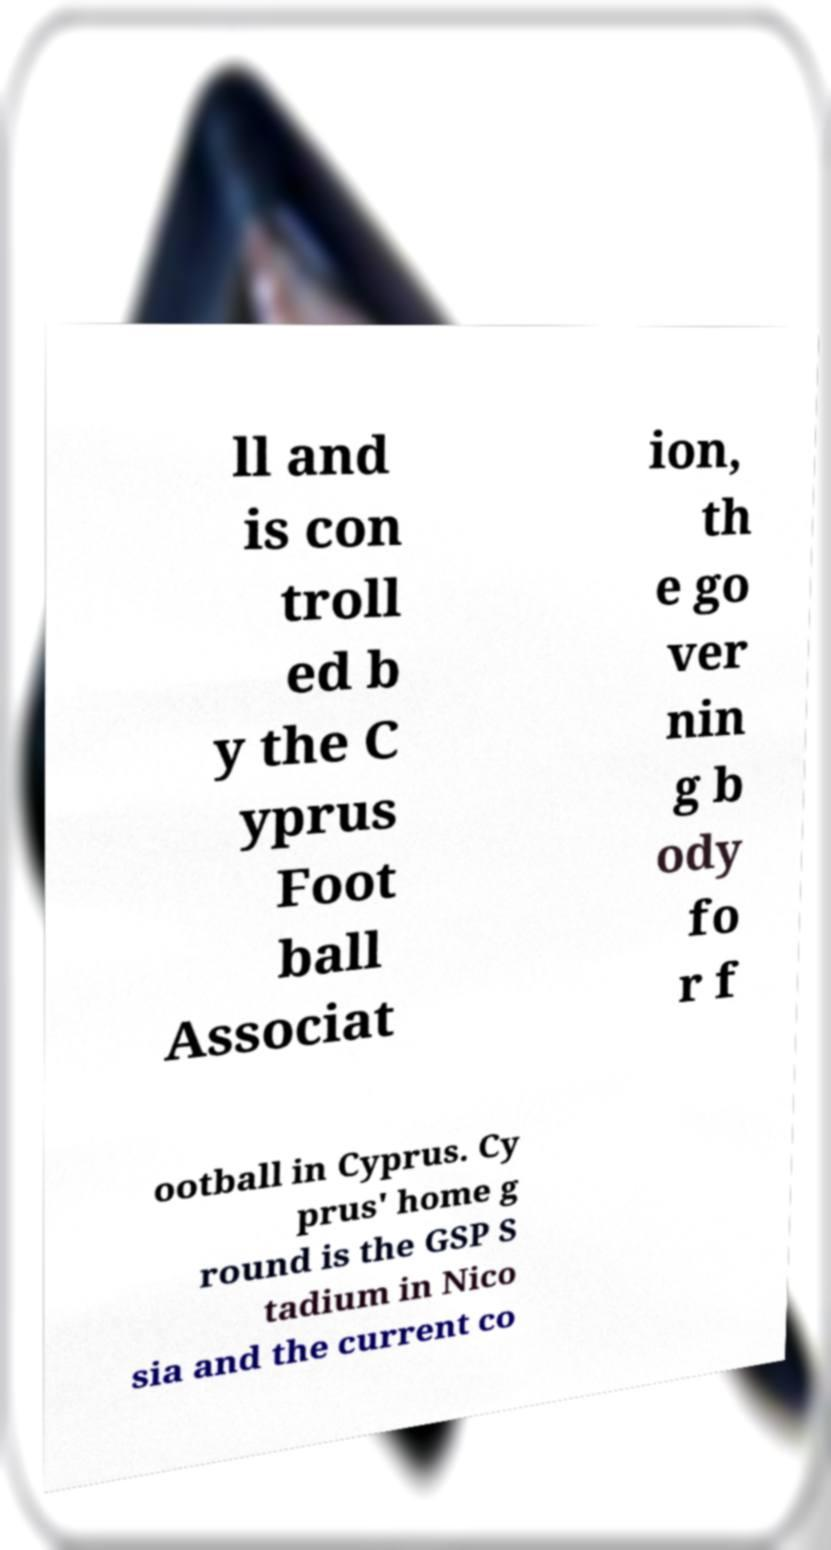There's text embedded in this image that I need extracted. Can you transcribe it verbatim? ll and is con troll ed b y the C yprus Foot ball Associat ion, th e go ver nin g b ody fo r f ootball in Cyprus. Cy prus' home g round is the GSP S tadium in Nico sia and the current co 